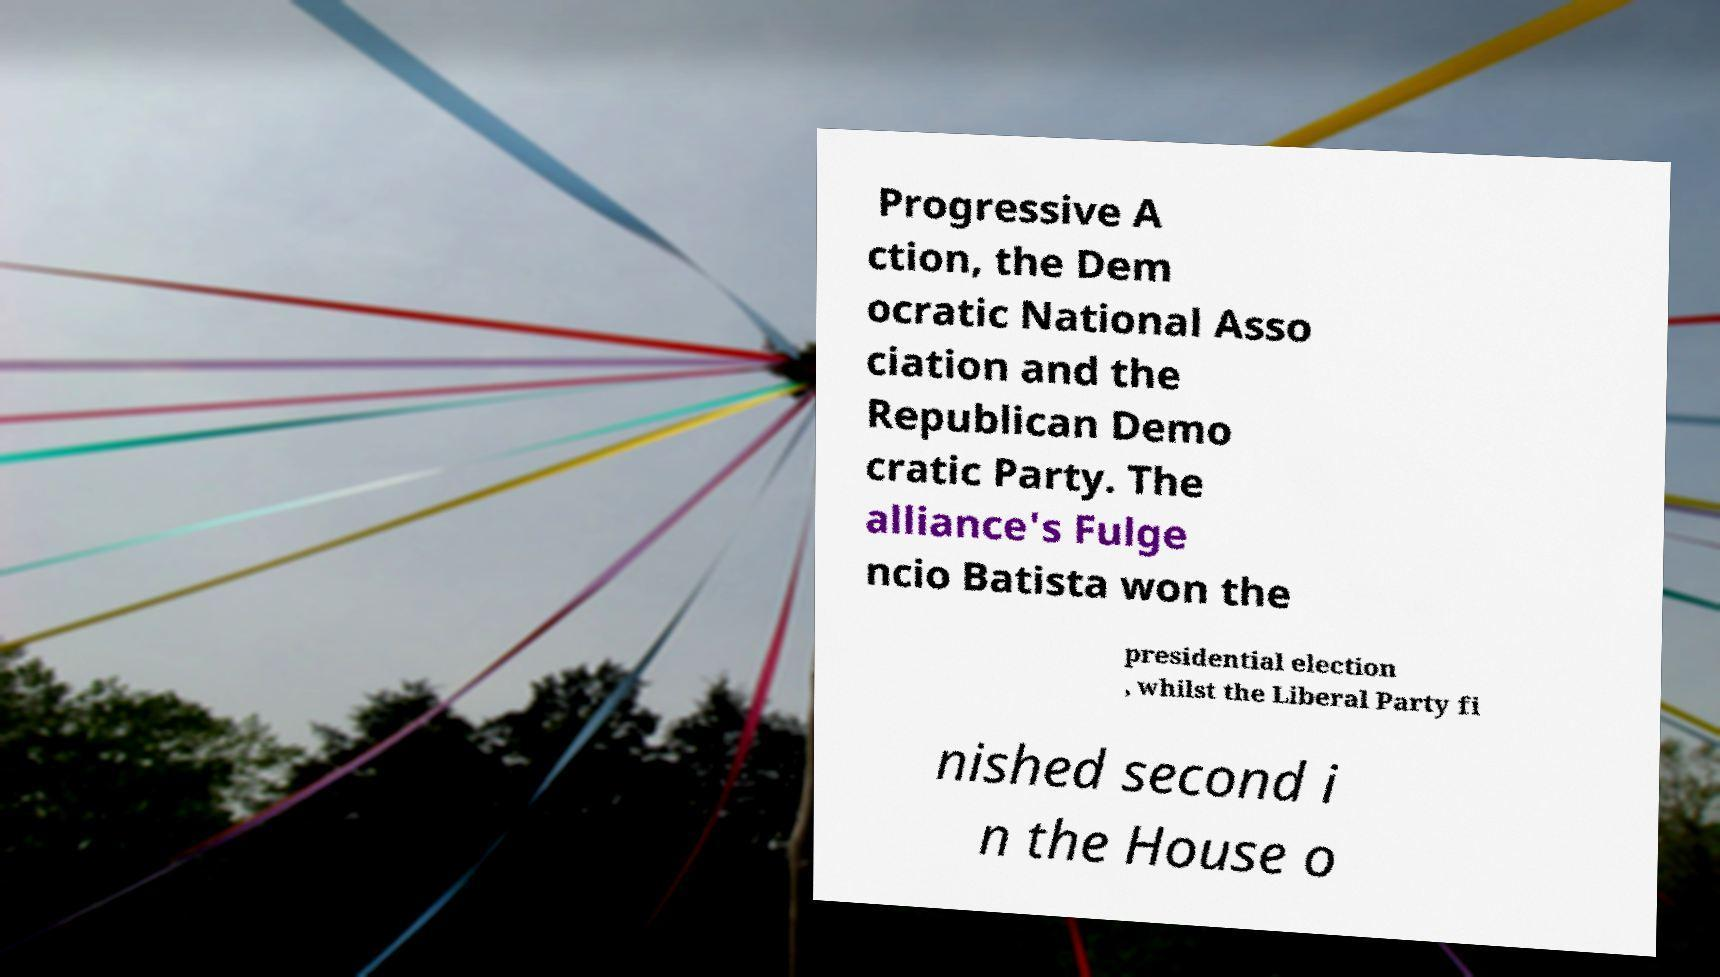There's text embedded in this image that I need extracted. Can you transcribe it verbatim? Progressive A ction, the Dem ocratic National Asso ciation and the Republican Demo cratic Party. The alliance's Fulge ncio Batista won the presidential election , whilst the Liberal Party fi nished second i n the House o 